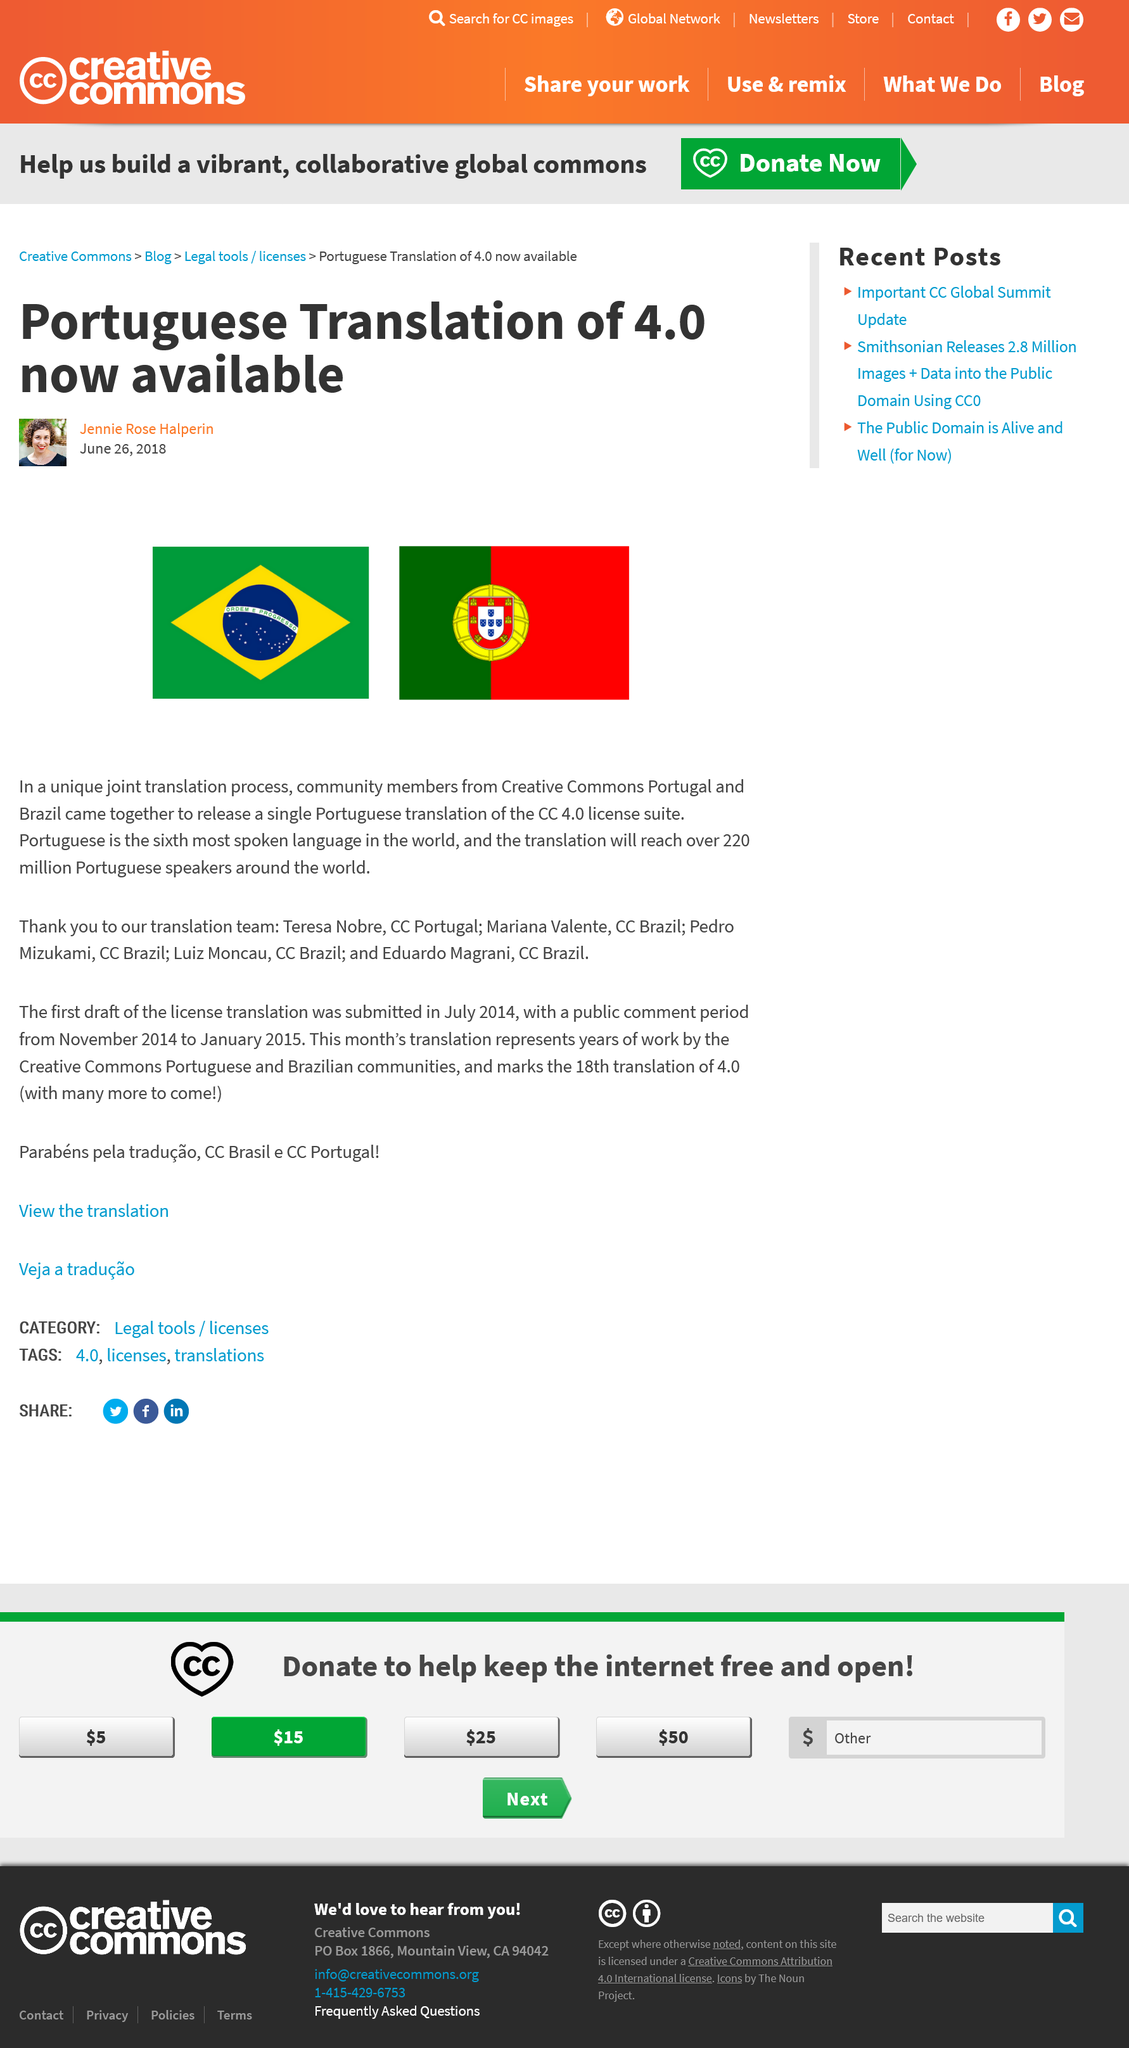Mention a couple of crucial points in this snapshot. Creative Commons Portugal and Brazil community members released a Portuguese translation of the CC 4.0 license suite. The Portuguese translation version 4.0 is now available. Portuguese is the 6th most spoken language in the world. 